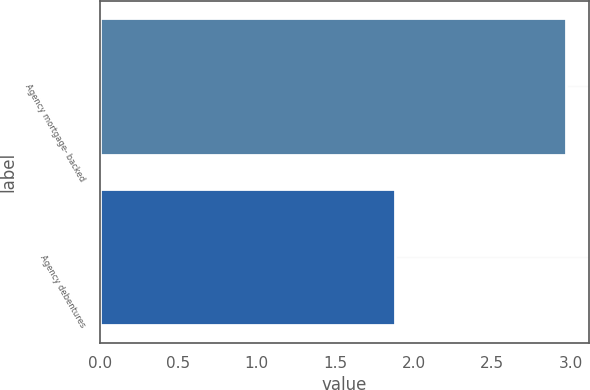Convert chart. <chart><loc_0><loc_0><loc_500><loc_500><bar_chart><fcel>Agency mortgage- backed<fcel>Agency debentures<nl><fcel>2.97<fcel>1.88<nl></chart> 